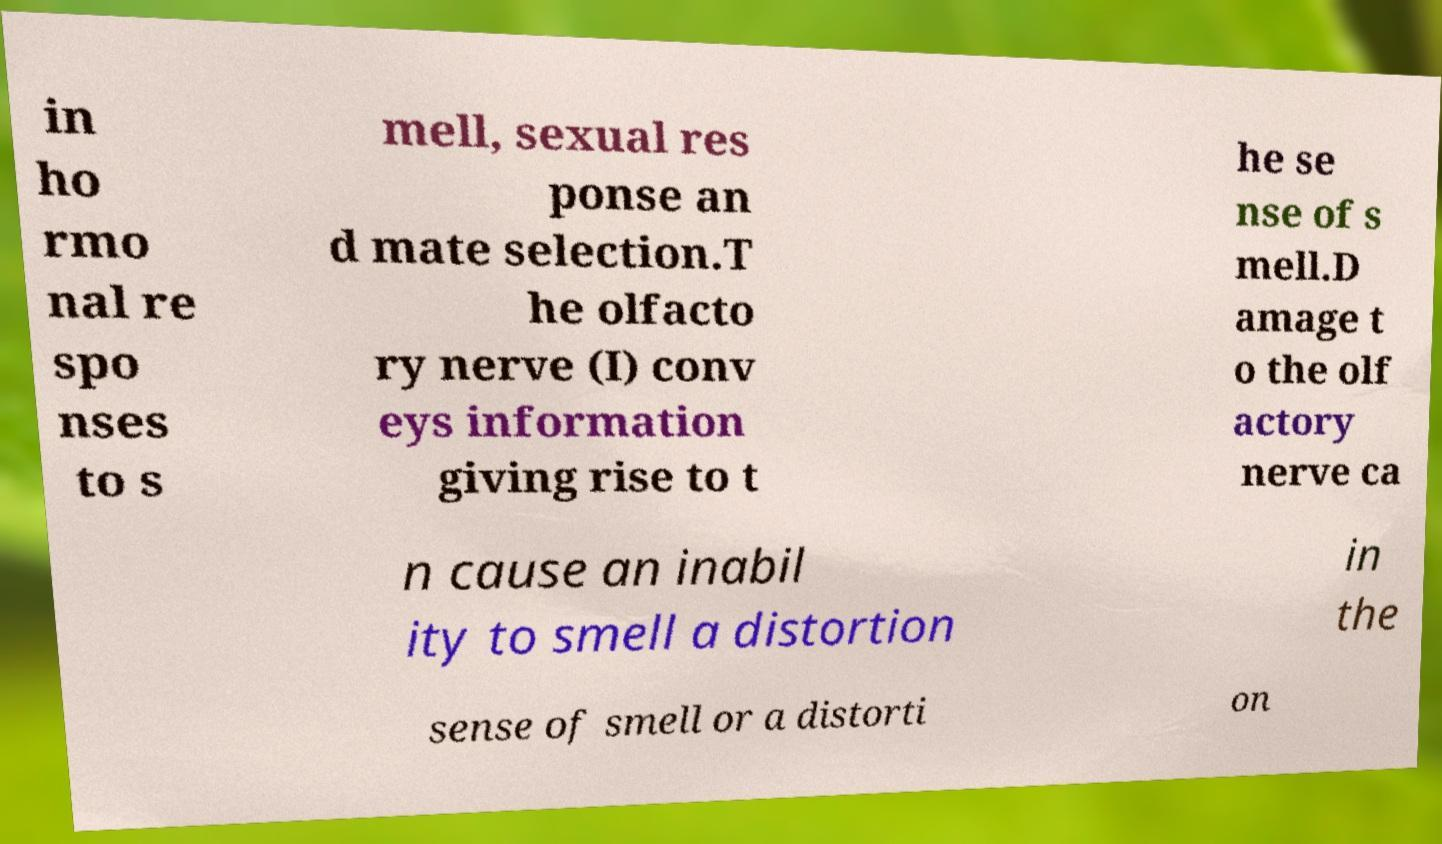For documentation purposes, I need the text within this image transcribed. Could you provide that? in ho rmo nal re spo nses to s mell, sexual res ponse an d mate selection.T he olfacto ry nerve (I) conv eys information giving rise to t he se nse of s mell.D amage t o the olf actory nerve ca n cause an inabil ity to smell a distortion in the sense of smell or a distorti on 